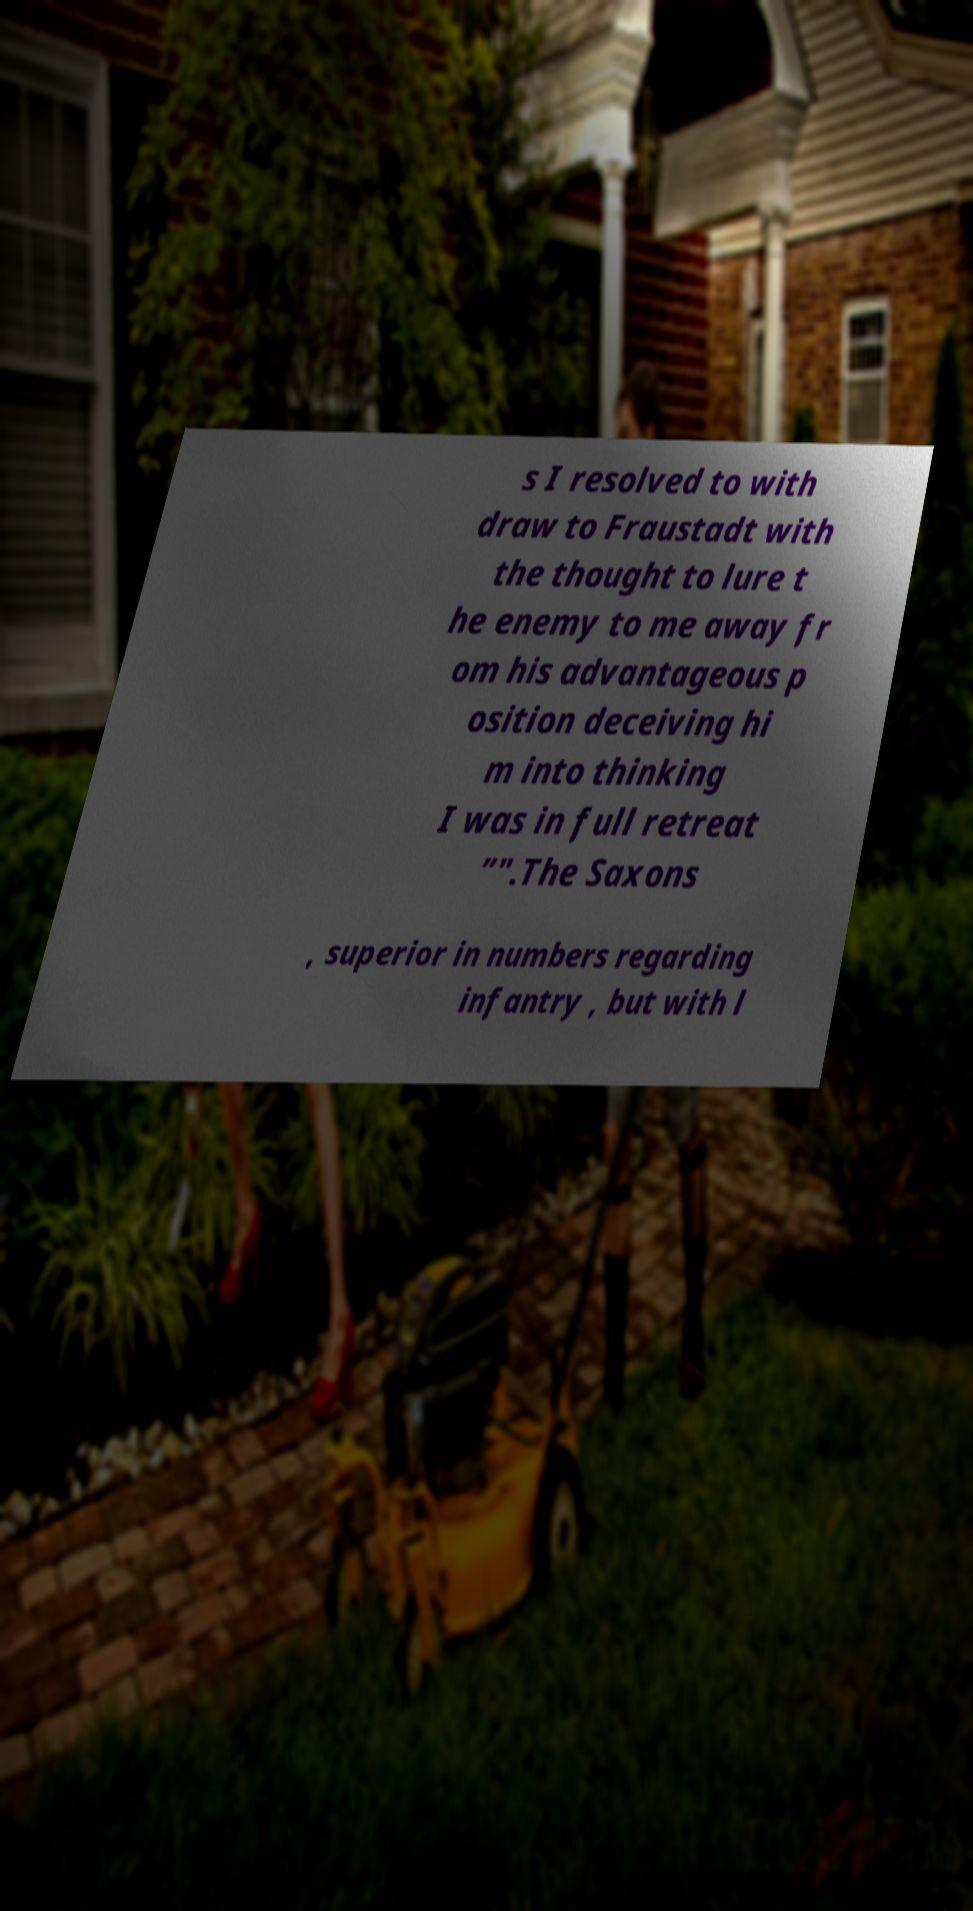Could you extract and type out the text from this image? s I resolved to with draw to Fraustadt with the thought to lure t he enemy to me away fr om his advantageous p osition deceiving hi m into thinking I was in full retreat ”".The Saxons , superior in numbers regarding infantry , but with l 